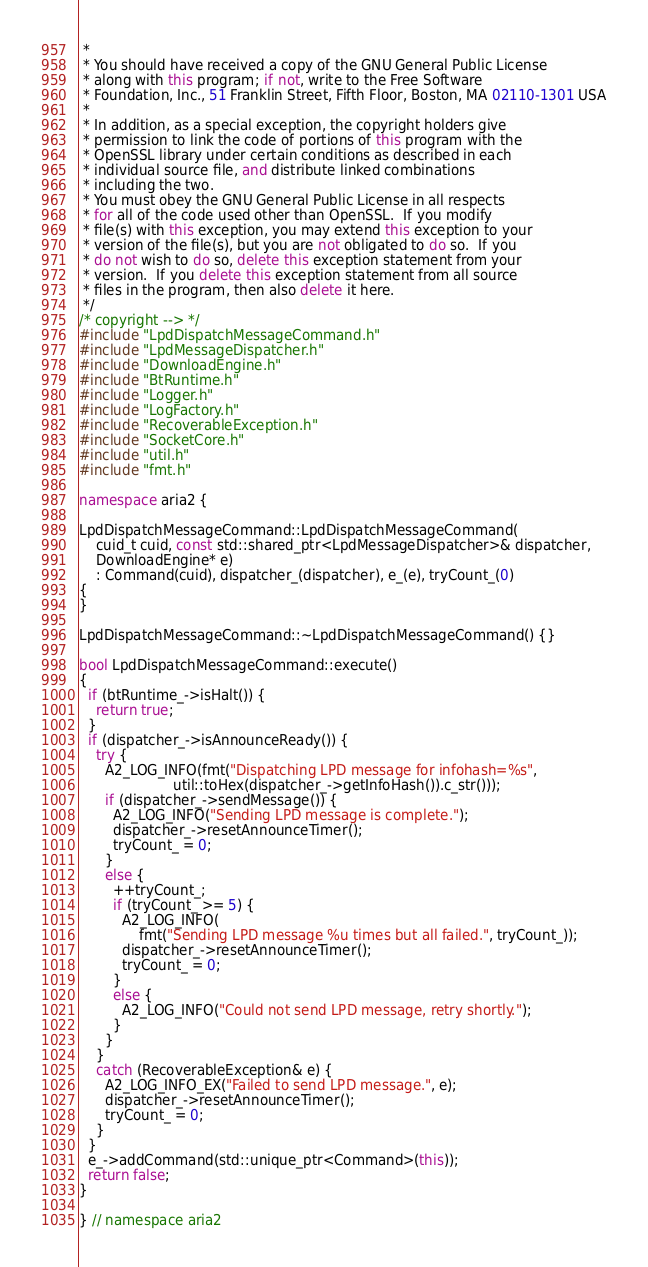Convert code to text. <code><loc_0><loc_0><loc_500><loc_500><_C++_> *
 * You should have received a copy of the GNU General Public License
 * along with this program; if not, write to the Free Software
 * Foundation, Inc., 51 Franklin Street, Fifth Floor, Boston, MA 02110-1301 USA
 *
 * In addition, as a special exception, the copyright holders give
 * permission to link the code of portions of this program with the
 * OpenSSL library under certain conditions as described in each
 * individual source file, and distribute linked combinations
 * including the two.
 * You must obey the GNU General Public License in all respects
 * for all of the code used other than OpenSSL.  If you modify
 * file(s) with this exception, you may extend this exception to your
 * version of the file(s), but you are not obligated to do so.  If you
 * do not wish to do so, delete this exception statement from your
 * version.  If you delete this exception statement from all source
 * files in the program, then also delete it here.
 */
/* copyright --> */
#include "LpdDispatchMessageCommand.h"
#include "LpdMessageDispatcher.h"
#include "DownloadEngine.h"
#include "BtRuntime.h"
#include "Logger.h"
#include "LogFactory.h"
#include "RecoverableException.h"
#include "SocketCore.h"
#include "util.h"
#include "fmt.h"

namespace aria2 {

LpdDispatchMessageCommand::LpdDispatchMessageCommand(
    cuid_t cuid, const std::shared_ptr<LpdMessageDispatcher>& dispatcher,
    DownloadEngine* e)
    : Command(cuid), dispatcher_(dispatcher), e_(e), tryCount_(0)
{
}

LpdDispatchMessageCommand::~LpdDispatchMessageCommand() {}

bool LpdDispatchMessageCommand::execute()
{
  if (btRuntime_->isHalt()) {
    return true;
  }
  if (dispatcher_->isAnnounceReady()) {
    try {
      A2_LOG_INFO(fmt("Dispatching LPD message for infohash=%s",
                      util::toHex(dispatcher_->getInfoHash()).c_str()));
      if (dispatcher_->sendMessage()) {
        A2_LOG_INFO("Sending LPD message is complete.");
        dispatcher_->resetAnnounceTimer();
        tryCount_ = 0;
      }
      else {
        ++tryCount_;
        if (tryCount_ >= 5) {
          A2_LOG_INFO(
              fmt("Sending LPD message %u times but all failed.", tryCount_));
          dispatcher_->resetAnnounceTimer();
          tryCount_ = 0;
        }
        else {
          A2_LOG_INFO("Could not send LPD message, retry shortly.");
        }
      }
    }
    catch (RecoverableException& e) {
      A2_LOG_INFO_EX("Failed to send LPD message.", e);
      dispatcher_->resetAnnounceTimer();
      tryCount_ = 0;
    }
  }
  e_->addCommand(std::unique_ptr<Command>(this));
  return false;
}

} // namespace aria2
</code> 